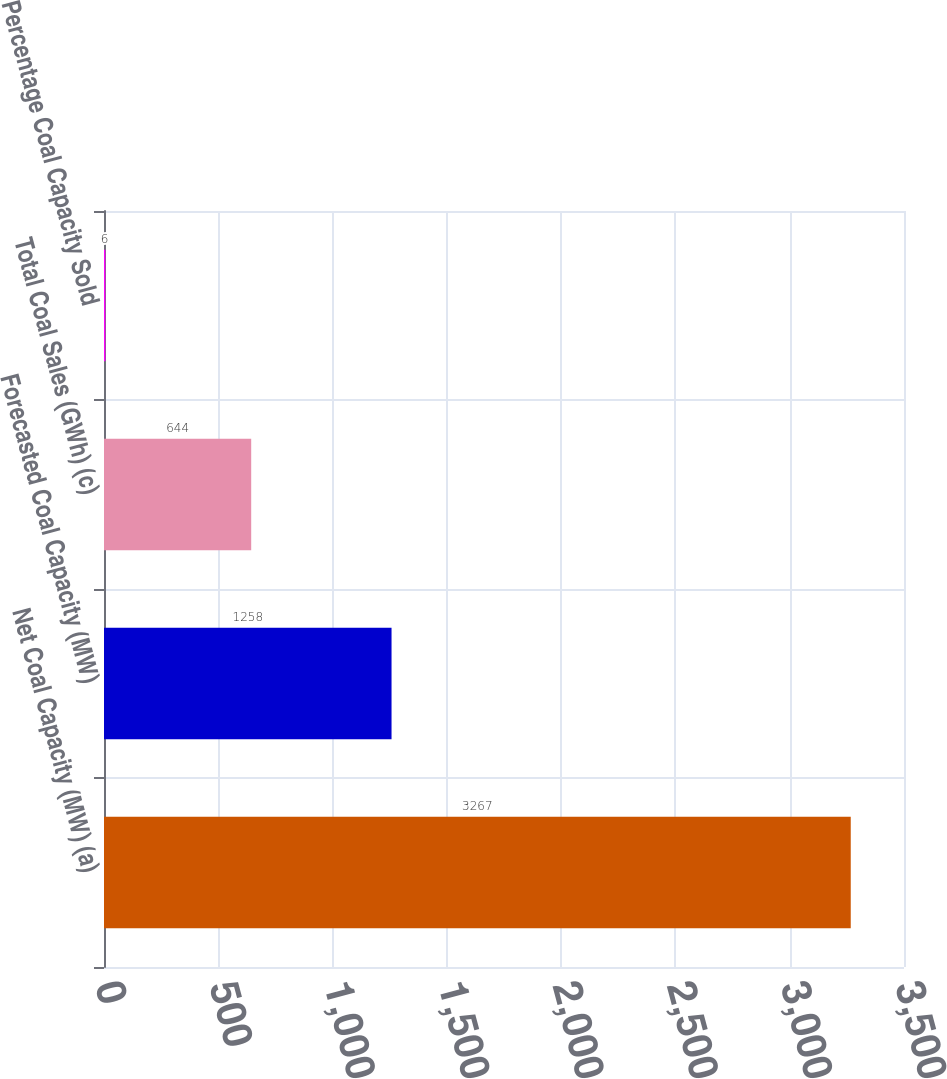<chart> <loc_0><loc_0><loc_500><loc_500><bar_chart><fcel>Net Coal Capacity (MW) (a)<fcel>Forecasted Coal Capacity (MW)<fcel>Total Coal Sales (GWh) (c)<fcel>Percentage Coal Capacity Sold<nl><fcel>3267<fcel>1258<fcel>644<fcel>6<nl></chart> 